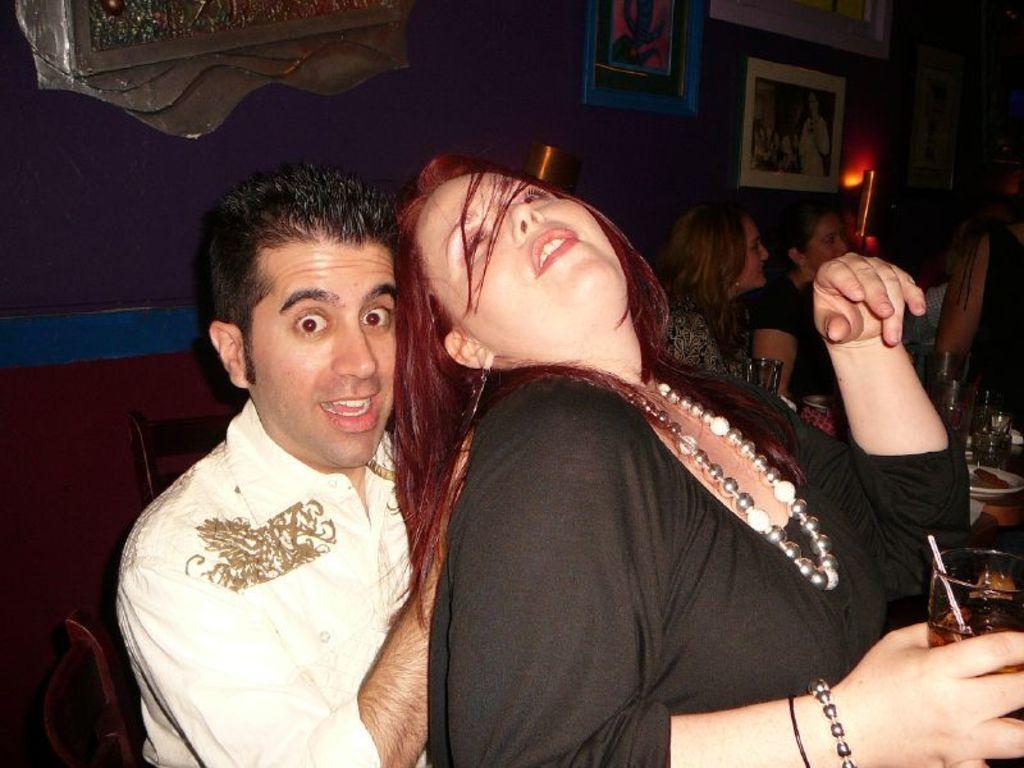Describe this image in one or two sentences. In this image, we can see few people. Here a woman is holding a glass with liquid. Background there is a wall, for photo frames, lights. Right side of the image, we can see some objects, glasses. 